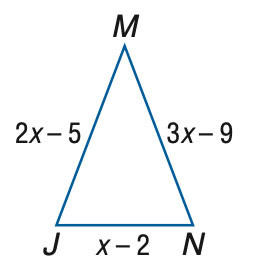Answer the mathemtical geometry problem and directly provide the correct option letter.
Question: Find M N if \triangle J M N is an isosceles triangle with J M \cong M N.
Choices: A: 2 B: 3 C: 4 D: 5 B 